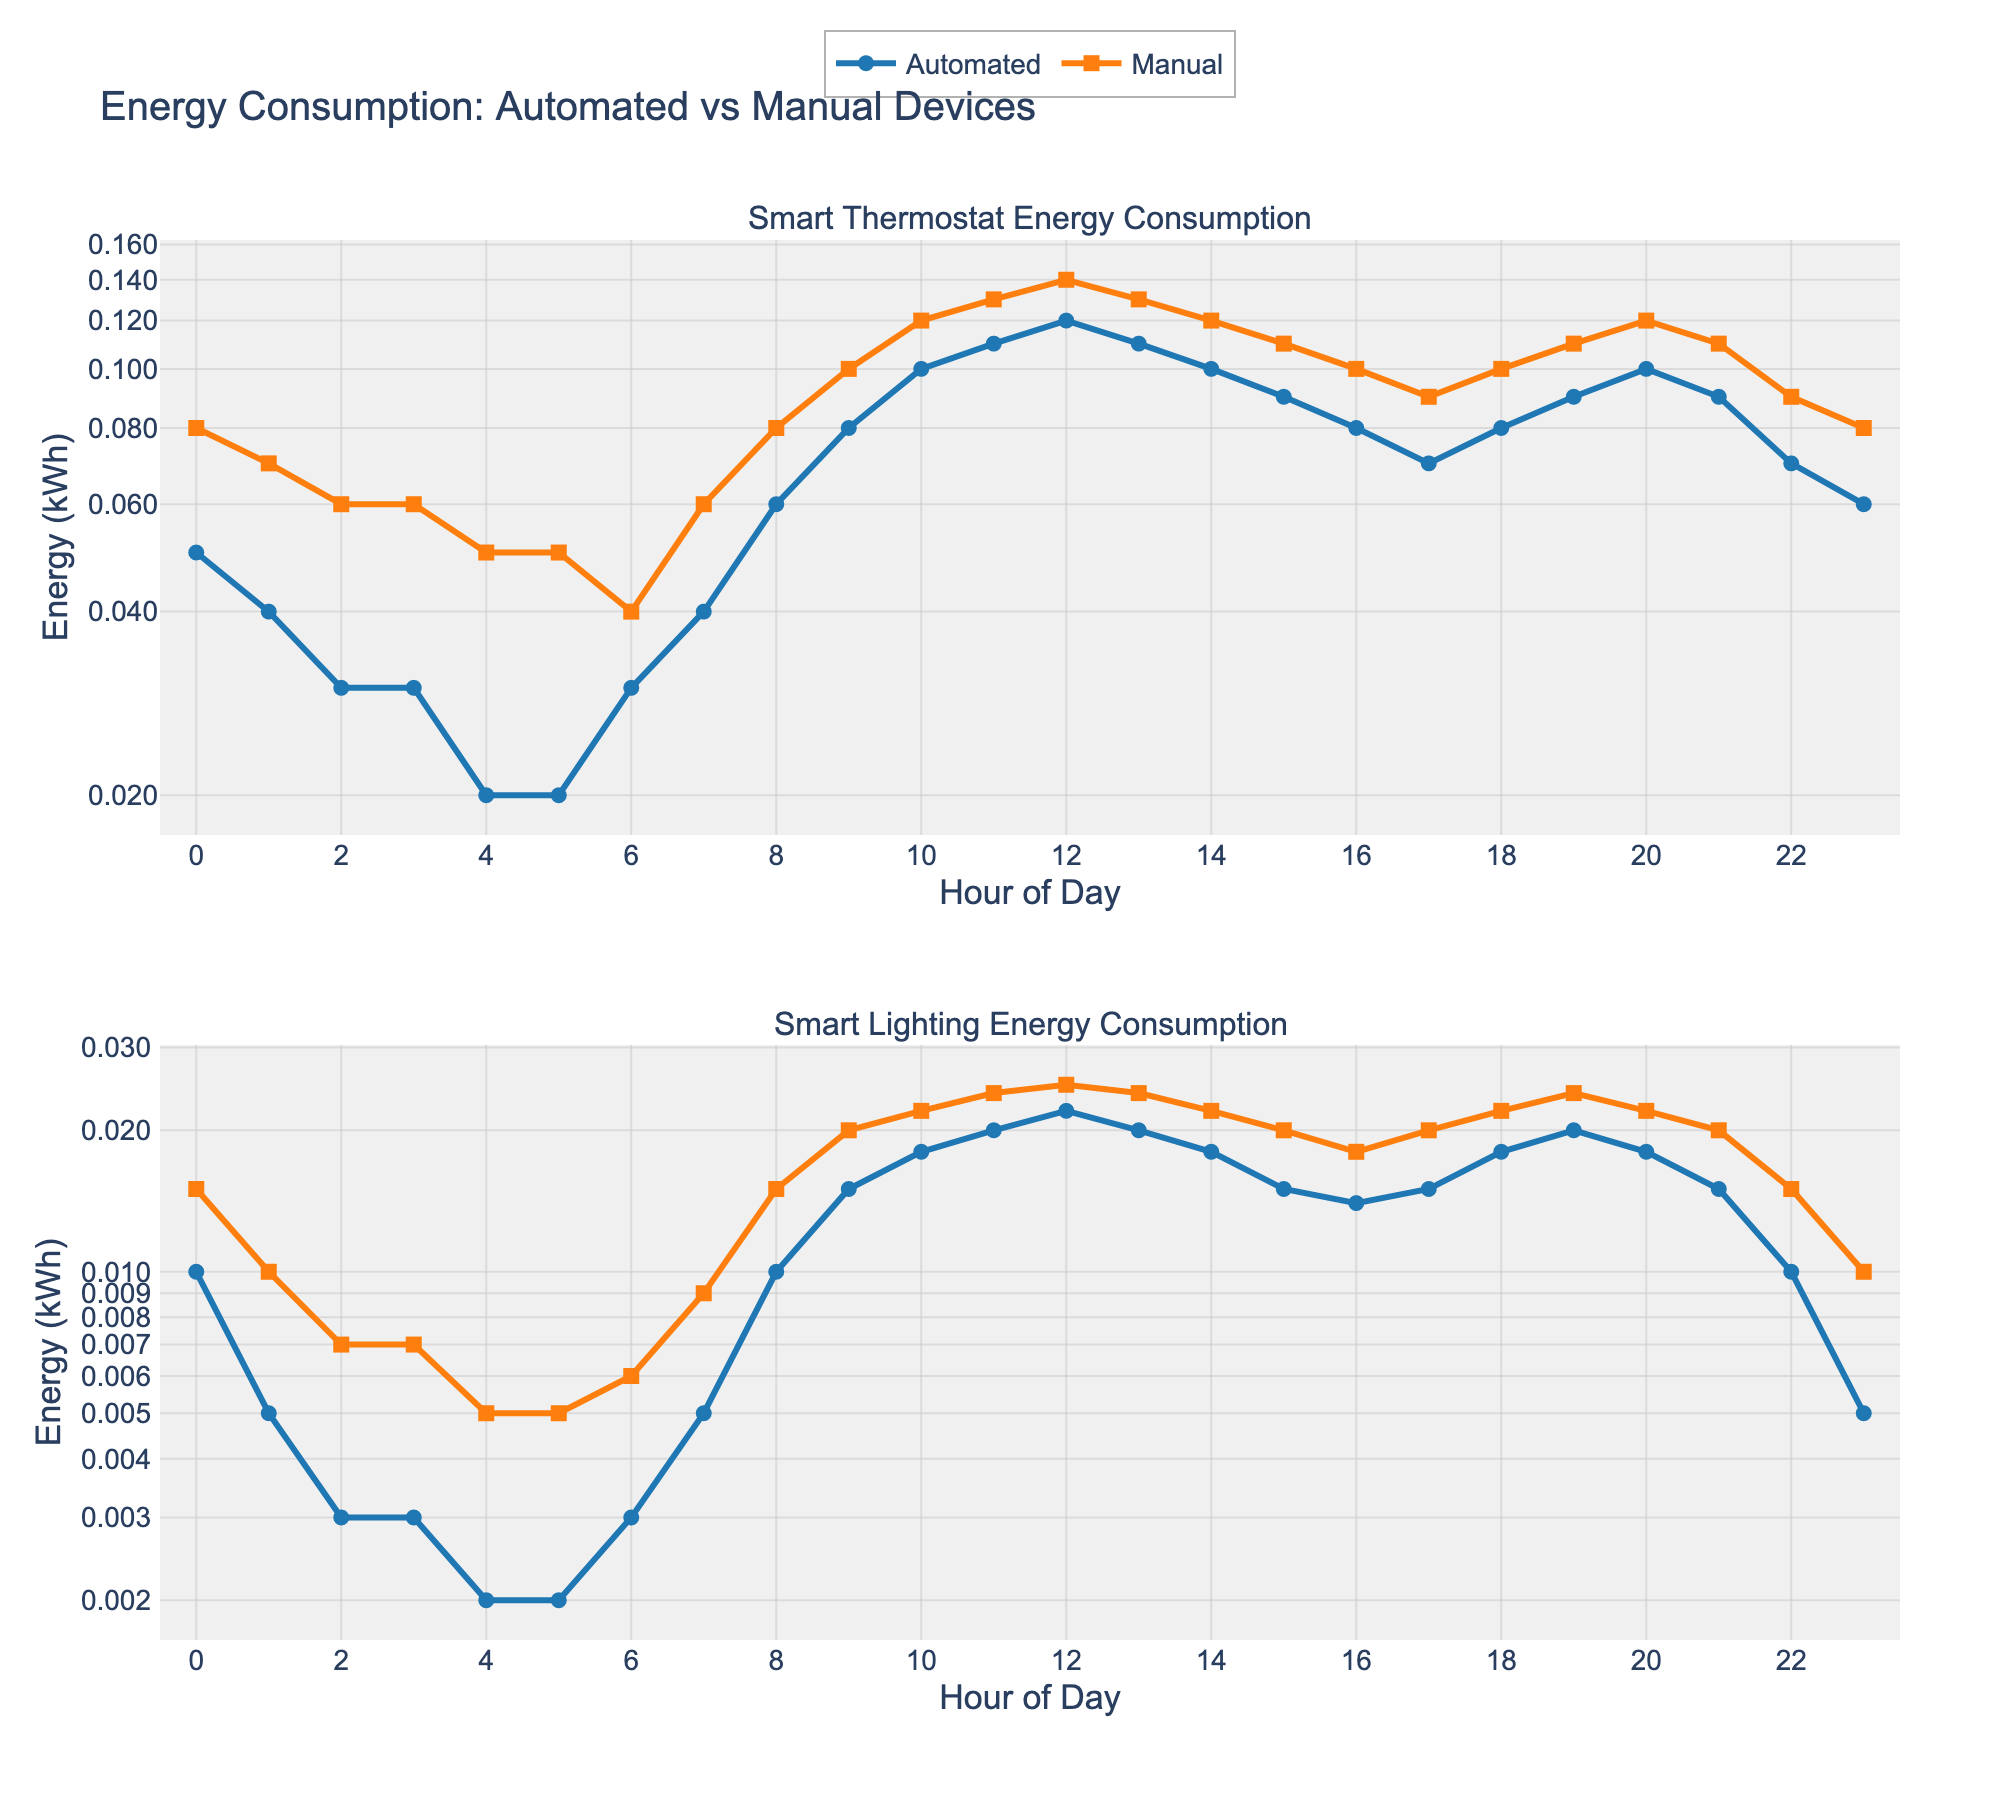What is the title of the figure? The title is located at the top of the figure and provides an overview of the content within the plots. Look at the top portion of the figure to find this information.
Answer: Energy Consumption: Automated vs Manual Devices What are the y-axis labels for both subplots? The y-axis labels, present along the side of each plot, indicate the type of data being measured on that axis. They provide context to the numerical values plotted.
Answer: Energy (kWh) At what hour does Smart Thermostat's automated energy consumption reach its peak? Examine the line representing 'Automated' for the Smart Thermostat in the top subplot. Identify the highest point and note the corresponding hour on the x-axis.
Answer: 12 By how much does the automated energy consumption for Smart Lighting increase between 0 and 12 hours? Find the 'Automated' energy consumption values for Smart Lighting at hour 0 and hour 12 within the bottom subplot. Subtract the value at hour 0 from the value at hour 12.
Answer: 0.021 (0.022 - 0.001) Which device and mode (automated or manual) show the least variability in energy consumption over the 24 hours? Compare the fluctuations in energy consumption across the 24-hour period for both devices and modes in their respective subplots. The line with the least variation in values is the answer.
Answer: Manual Smart Thermostat How does the automated energy consumption for Smart Lighting change between 6 AM and 6 PM? Examine the bottom subplot for the 'Automated' line. Note the energy consumption at hour 6 (6 AM) and at hour 18 (6 PM) and describe the trend (increase, decrease, or constant).
Answer: Increase What is the difference in energy consumption between automated and manual modes for Smart Thermostat at 9 AM? Look at the Smart Thermostat subplot at hour 9. Find the 'Automated' and 'Manual' energy consumption values and subtract the automated value from the manual value.
Answer: 0.02 (0.1 - 0.08) On a log scale, which hour shows a crossover between automated and manual energy consumption for Smart Lighting? In the bottom subplot, identify any hour where the 'Automated' and 'Manual' lines intersect, indicating equal energy consumption.
Answer: 18 Which mode (automated or manual) for Smart Lighting has the highest energy consumption at 10 AM, and what is the value? Focus on the bottom subplot at hour 10. Compare the 'Automated' and 'Manual' values and note which is higher, then provide the value.
Answer: Manual, 0.022 What is the automated energy consumption for Smart Thermostat at 3 AM? Check the top subplot at hour 3 and locate the data point for 'Automated' energy consumption.
Answer: 0.03 Considering the log scale, why might it be useful to use a log scale for this figure? A log scale is particularly useful to visualize data with a wide range of values, as it compresses large data values and expands small values, making patterns and differences more discernible. It can highlight variations that might be less obvious on a linear scale.
Answer: To ease visualizing wide range data Is there an hour when the Smart Lighting's automated and manual energy consumption values are nearly the same? If yes, at which hour(s)? Inspect the bottom subplot for hours where the 'Automated' and 'Manual' lines are closest to each other, considering the logarithmic scale.
Answer: 20 